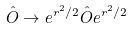Convert formula to latex. <formula><loc_0><loc_0><loc_500><loc_500>\hat { O } \rightarrow e ^ { r ^ { 2 } / 2 } \hat { O } e ^ { r ^ { 2 } / 2 }</formula> 